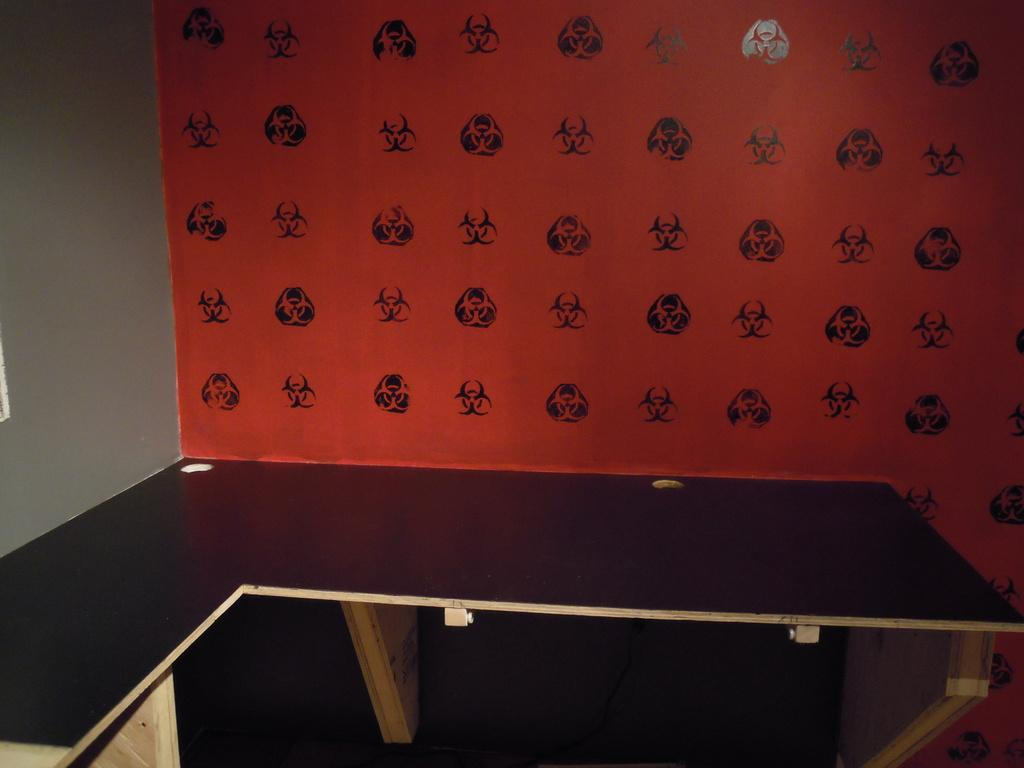What type of surface is visible in the image? There is a wooden platform in the image. What can be seen on the left side of the image? There is a wall painted with white paint on the left side of the image. How does the calendar contribute to the pollution in the image? There is no calendar present in the image, so it cannot contribute to any pollution. 